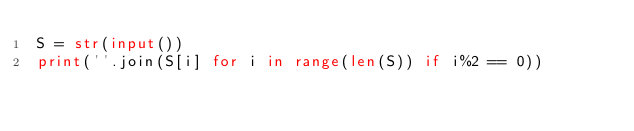<code> <loc_0><loc_0><loc_500><loc_500><_Python_>S = str(input())
print(''.join(S[i] for i in range(len(S)) if i%2 == 0))</code> 